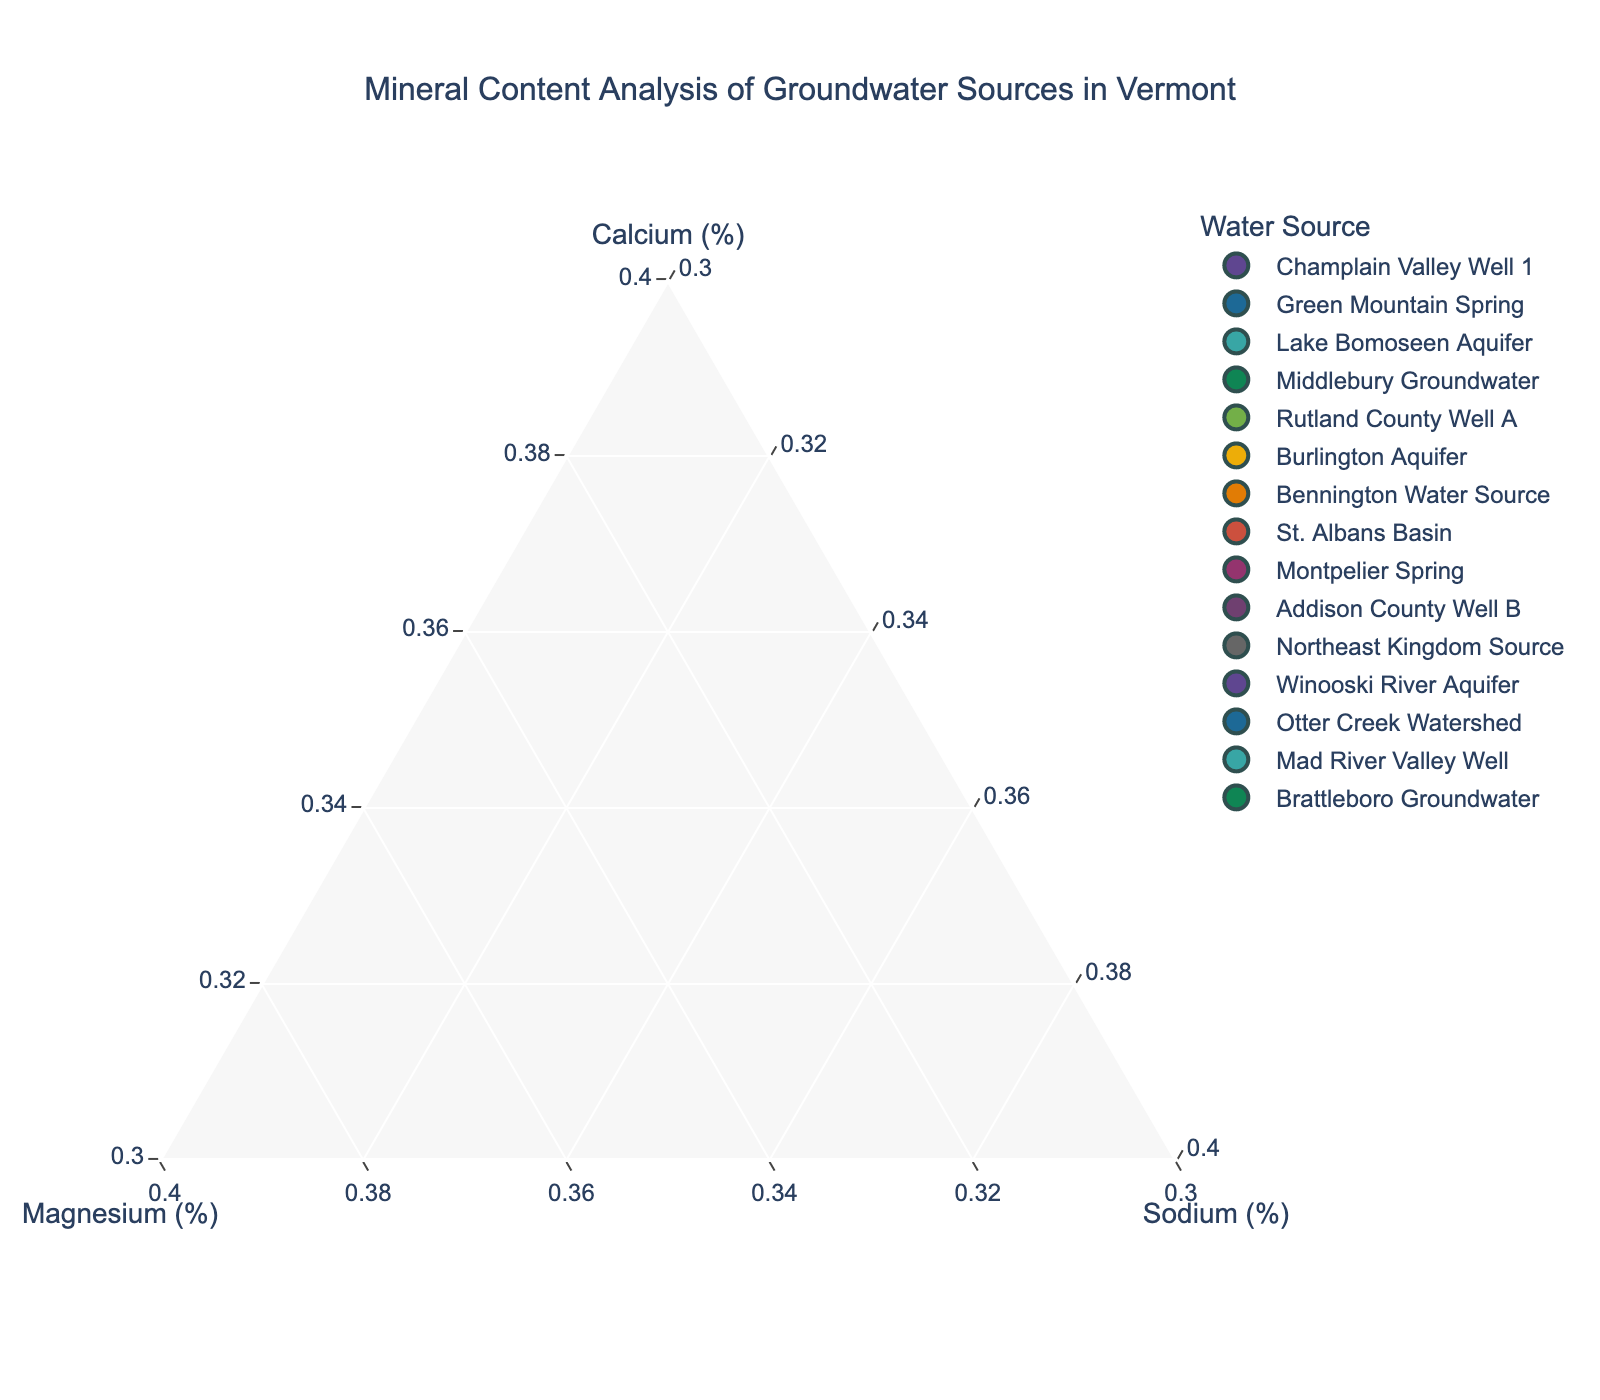Which site has the highest proportion of Magnesium? By looking at the plot, find the point that is closest to the Magnesium axis and farthest from the origin along the Magnesium (%). The Northeast Kingdom Source is positioned closest to the Magnesium axis with 50% Magnesium.
Answer: Northeast Kingdom Source What's the title of the figure? The title is typically displayed at the top center of the figure. In this case, look at the upper part of the plot to identify the title.
Answer: Mineral Content Analysis of Groundwater Sources in Vermont How many data points are presented in the plot? Count the number of distinct markers in the plot, each representing a unique groundwater source. Here, there are 15 markers, one for each groundwater source listed.
Answer: 15 Which site has an equal Magnesium and Calcium percentage? Identify the point where the Magnesium and Calcium percentages are equal by comparing the markers' positions. The Green Mountain Spring has 45% Magnesium and 40% Calcium, which is not equal. No site has equal Magnesium and Calcium percentages in this plot.
Answer: None Which sites have the same proportions of minerals (Calcium, Magnesium, Sodium)? Locate and compare the data points to find any that overlap exactly. Champlain Valley Well 1 and Addison County Well B both have the proportions 65% Calcium, 25% Magnesium, and 10% Sodium.
Answer: Champlain Valley Well 1, Addison County Well B Is there a trend of increasing Calcium and decreasing Magnesium among the sites? Examine the spatial arrangement of the points. There is a general trend that as Calcium increases, Magnesium often decreases, although it is not universally true for all points.
Answer: Yes, generally Which site has the lowest Sodium percentage? Identify the point closest to the base of the Sodium axis, indicating the smallest proportion of Sodium. All sites have a minimum of 10%, but Montpelier Spring, Middlebury Groundwater, Burlington Aquifer, and others have exactly 10%.
Answer: Montpelier Spring (and others) Which site has an equal split of Calcium and Magnesium? Find the point where the proportions of Calcium and Magnesium are exactly 50% each. No points on the plot represent an equal split of Calcium and Magnesium.
Answer: None What are the axes titles in the ternary plot? The axes titles are positioned along the edges of the plot, each labeling the axis for Calcium, Magnesium, and Sodium.
Answer: Calcium (%), Magnesium (%), Sodium (%) Which sites have a higher percentage of Magnesium than Calcium? Compare the proportions of Magnesium and Calcium for all sites. Green Mountain Spring (45% Mg, 40% Ca) and Mad River Valley Well (45% Mg, 45% Ca, which is not higher but equal for Ca and Mg).
Answer: Green Mountain Spring, Mad River Valley Well 